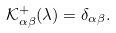<formula> <loc_0><loc_0><loc_500><loc_500>\mathcal { K } ^ { + } _ { \alpha \beta } ( \lambda ) = \delta _ { \alpha \beta } .</formula> 